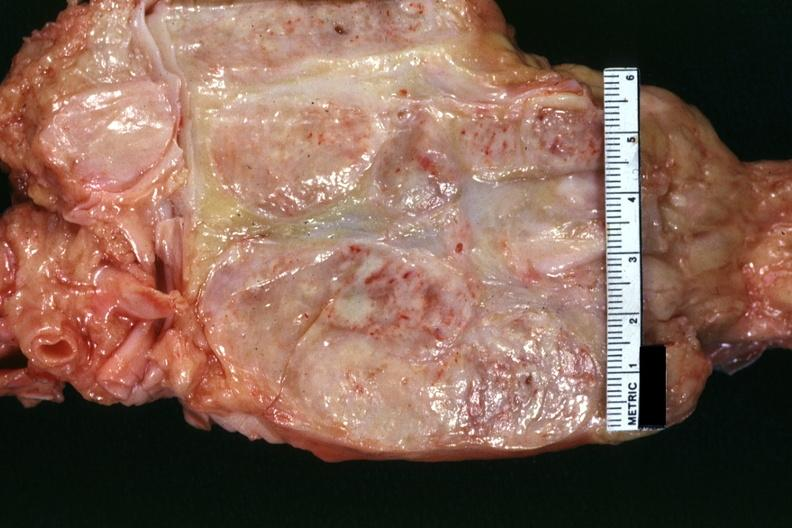how is excellent example cut surface of nodes seen externally in slide shows matting and necrosis?
Answer the question using a single word or phrase. Focal 